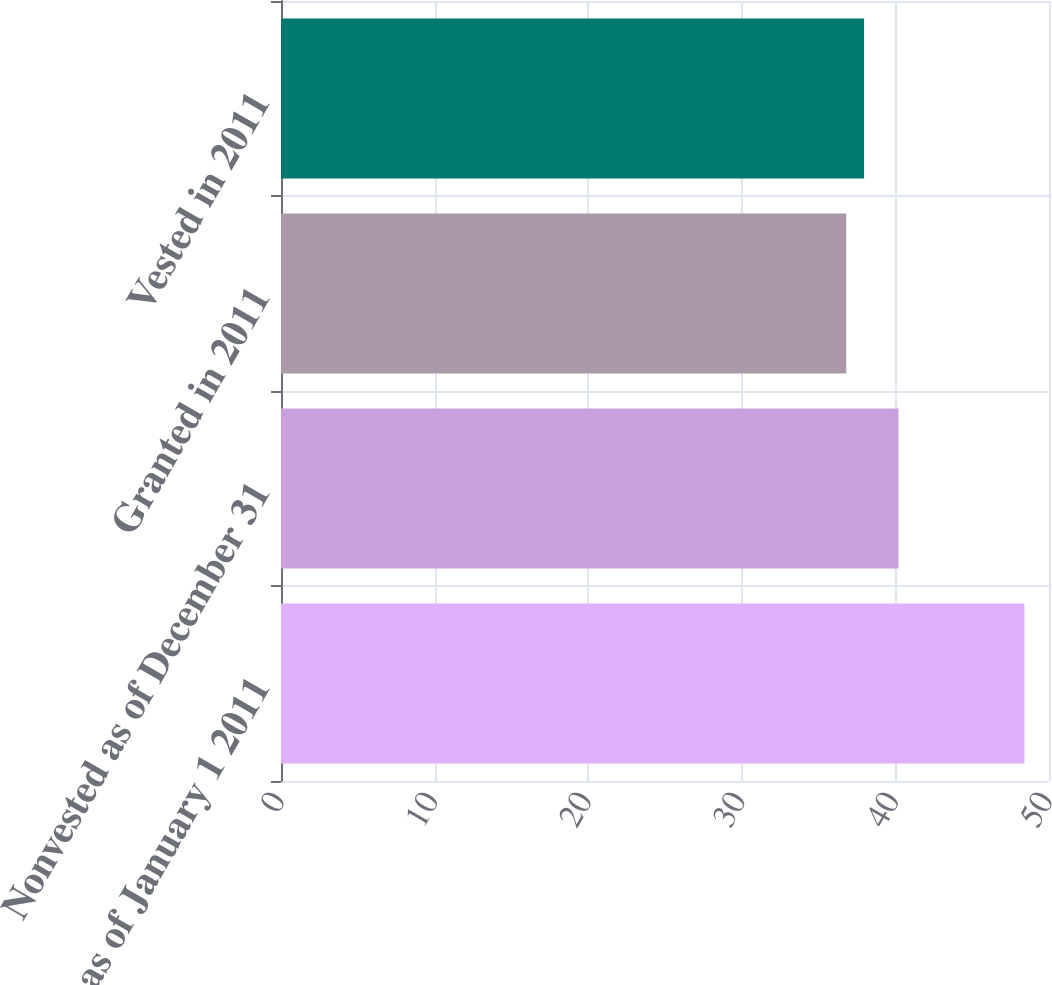<chart> <loc_0><loc_0><loc_500><loc_500><bar_chart><fcel>Nonvested as of January 1 2011<fcel>Nonvested as of December 31<fcel>Granted in 2011<fcel>Vested in 2011<nl><fcel>48.4<fcel>40.2<fcel>36.8<fcel>37.96<nl></chart> 